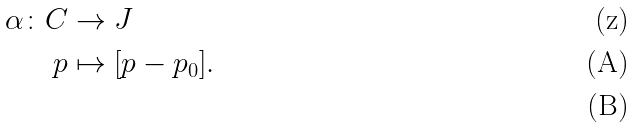Convert formula to latex. <formula><loc_0><loc_0><loc_500><loc_500>\alpha \colon C & \rightarrow J \\ p & \mapsto [ p - p _ { 0 } ] . \\</formula> 